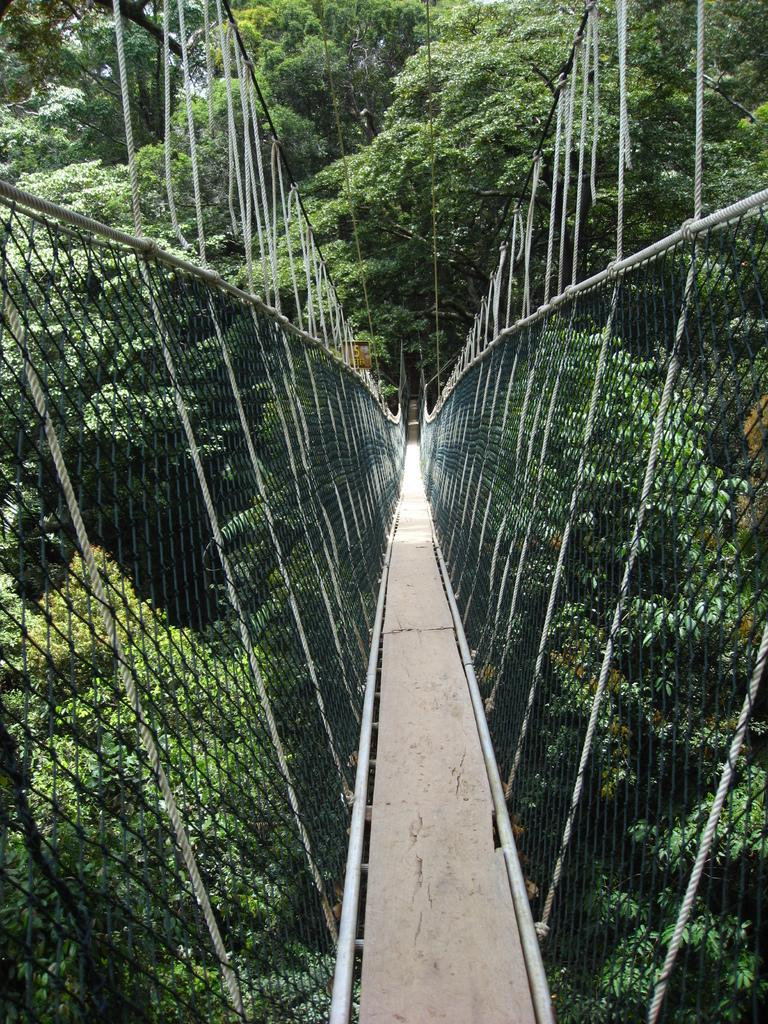What is the main structure in the picture? There is a bridge in the picture. What can be seen in the background of the picture? There are trees in the background of the picture. What feature is present on both sides of the bridge? The bridge has nets on both sides. What message of peace is conveyed by the hands in the image? There are no hands present in the image, so no message of peace can be conveyed. 